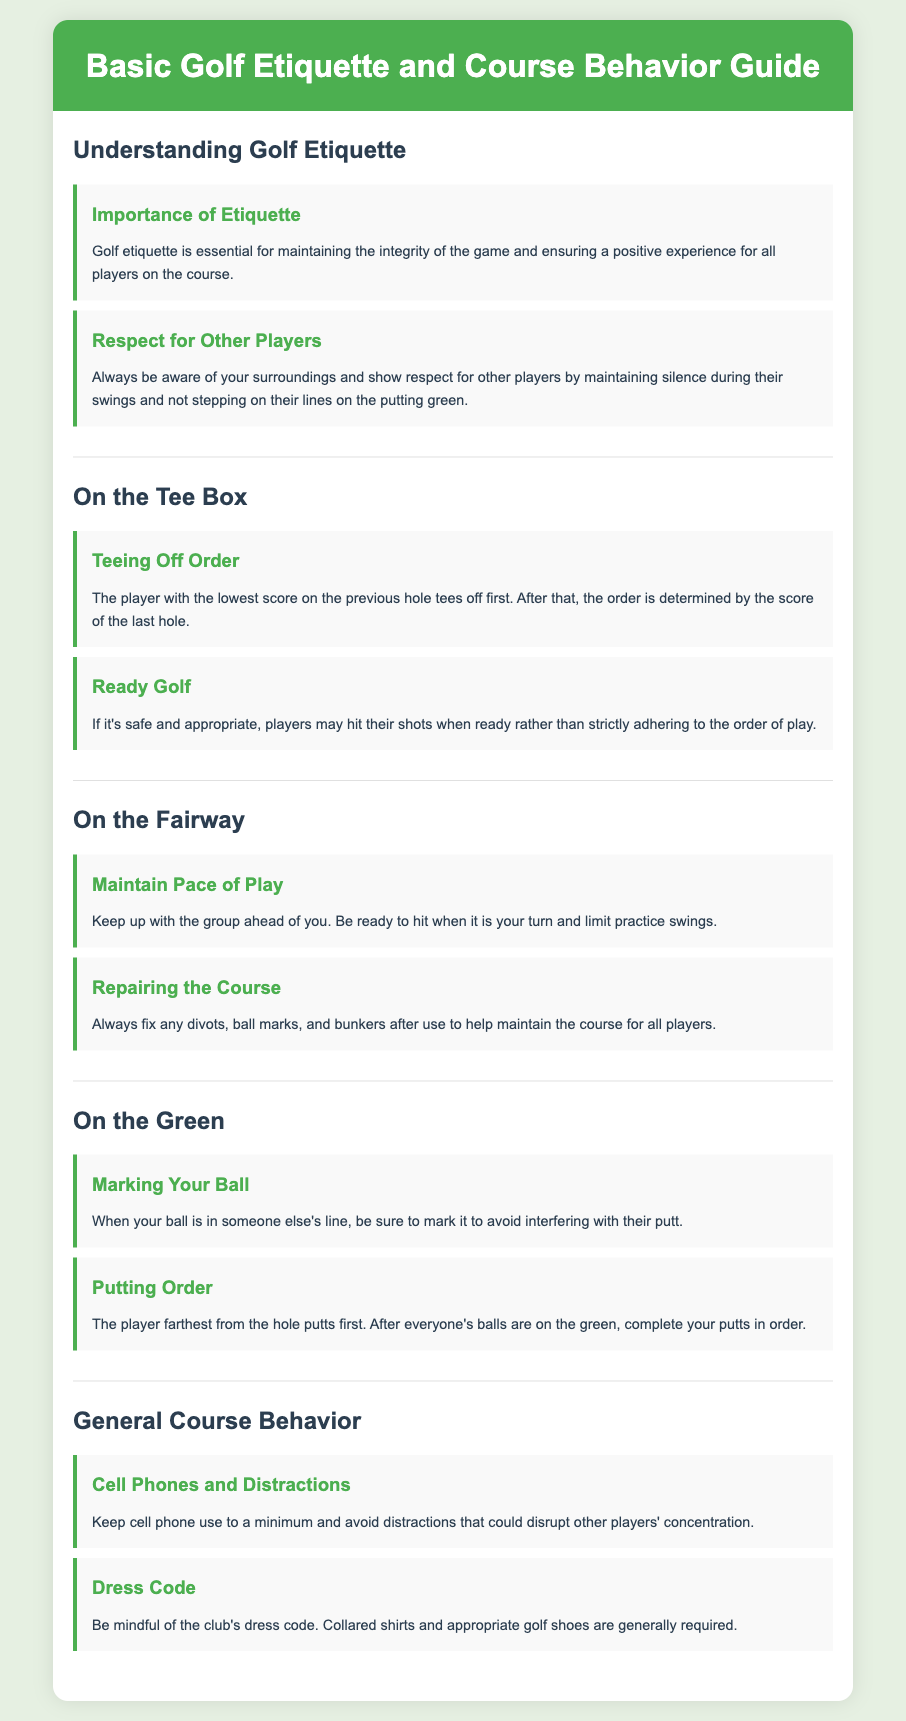What is the main focus of golf etiquette? The main focus of golf etiquette is to maintain the integrity of the game and ensure a positive experience for all players on the course.
Answer: Integrity of the game Who tees off first on the Tee Box? The player with the lowest score on the previous hole tees off first.
Answer: Lowest score What should players do to help maintain the course? Players should always fix any divots, ball marks, and bunkers after use.
Answer: Fix divots What is the putting order on the green? The player farthest from the hole putts first.
Answer: Farthest from the hole Why should you keep cell phone use to a minimum? To avoid distractions that could disrupt other players' concentration.
Answer: Avoid distractions What is a general requirement for golf attire? A collared shirt is generally required according to the dress code.
Answer: Collared shirts 